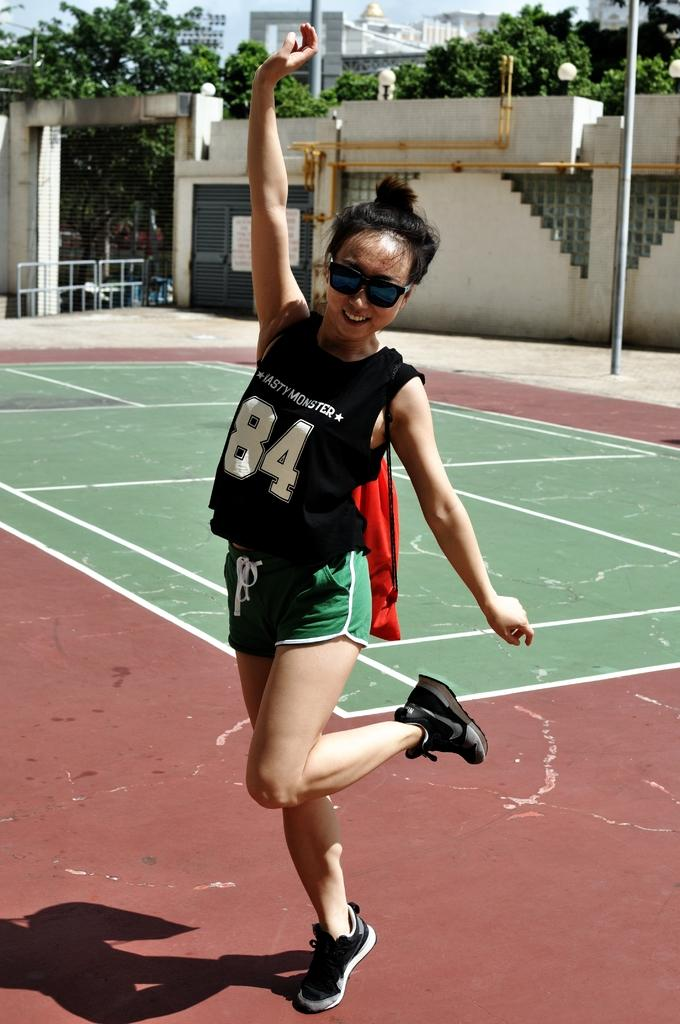<image>
Share a concise interpretation of the image provided. The happy girl posing in the picture has the number 84 on her top. 